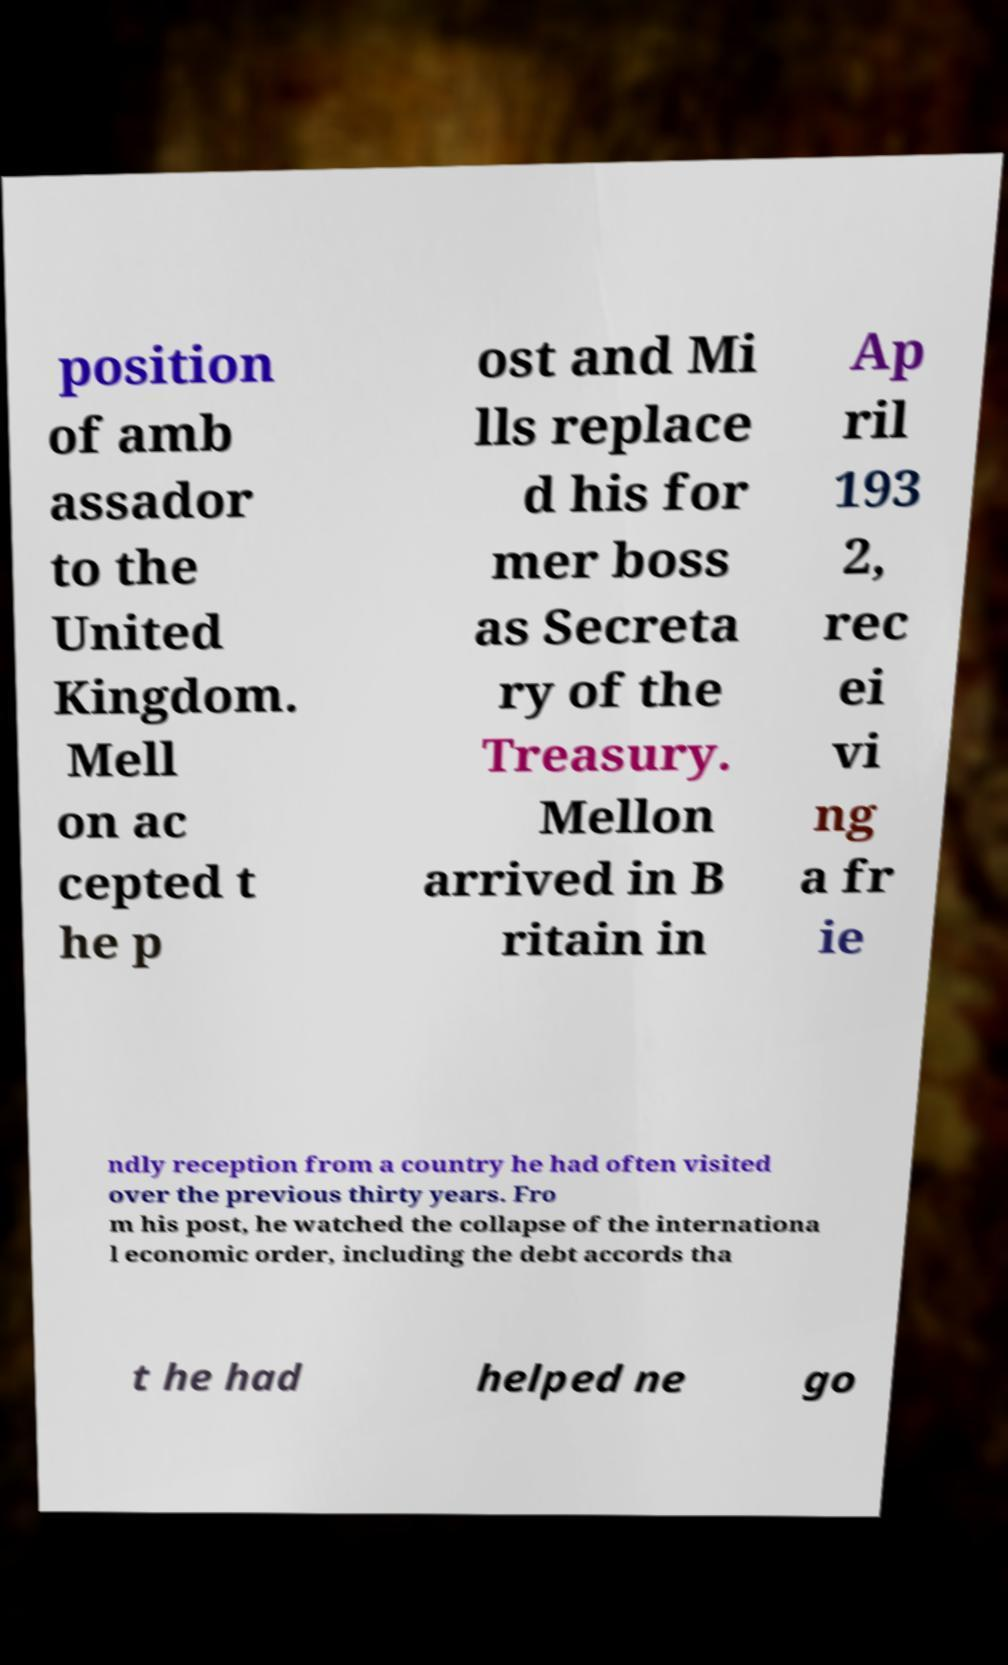Please read and relay the text visible in this image. What does it say? position of amb assador to the United Kingdom. Mell on ac cepted t he p ost and Mi lls replace d his for mer boss as Secreta ry of the Treasury. Mellon arrived in B ritain in Ap ril 193 2, rec ei vi ng a fr ie ndly reception from a country he had often visited over the previous thirty years. Fro m his post, he watched the collapse of the internationa l economic order, including the debt accords tha t he had helped ne go 